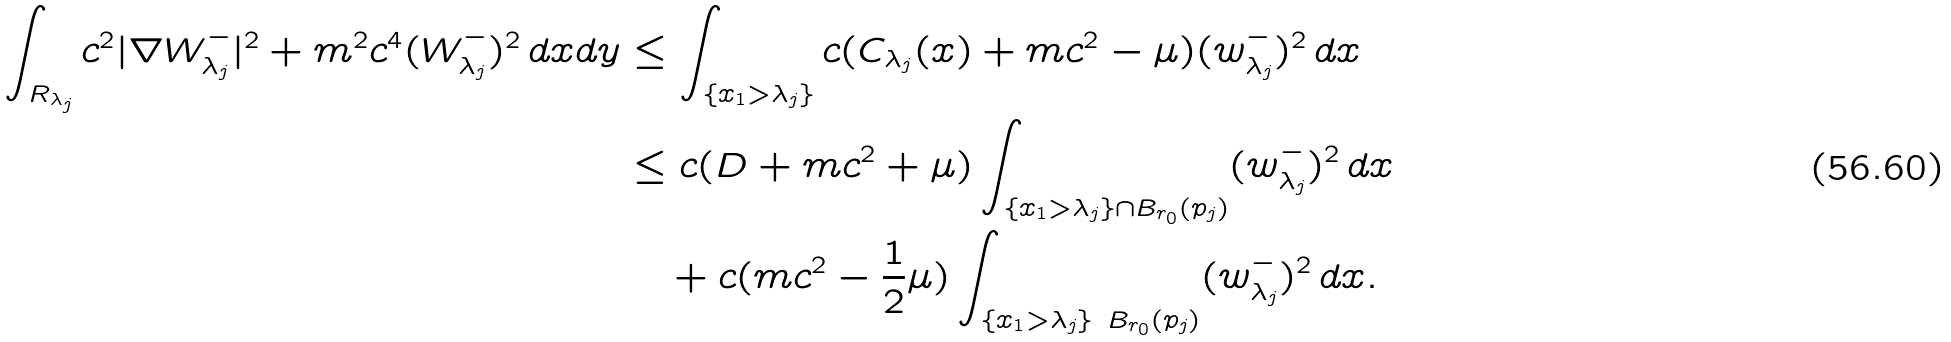Convert formula to latex. <formula><loc_0><loc_0><loc_500><loc_500>\int _ { R _ { \lambda _ { j } } } c ^ { 2 } | \nabla W _ { \lambda _ { j } } ^ { - } | ^ { 2 } + m ^ { 2 } c ^ { 4 } ( W _ { \lambda _ { j } } ^ { - } ) ^ { 2 } \, d x d y & \leq \int _ { \{ x _ { 1 } > { \lambda _ { j } } \} } c ( C _ { \lambda _ { j } } ( x ) + m c ^ { 2 } - \mu ) ( w _ { \lambda _ { j } } ^ { - } ) ^ { 2 } \, d x \\ & \leq c ( D + m c ^ { 2 } + \mu ) \int _ { \{ x _ { 1 } > { \lambda _ { j } } \} \cap B _ { r _ { 0 } } ( p _ { j } ) } ( w _ { \lambda _ { j } } ^ { - } ) ^ { 2 } \, d x \\ & \quad + c ( m c ^ { 2 } - \frac { 1 } { 2 } \mu ) \int _ { \{ x _ { 1 } > { \lambda _ { j } } \} \ B _ { r _ { 0 } } ( p _ { j } ) } ( w _ { \lambda _ { j } } ^ { - } ) ^ { 2 } \, d x .</formula> 